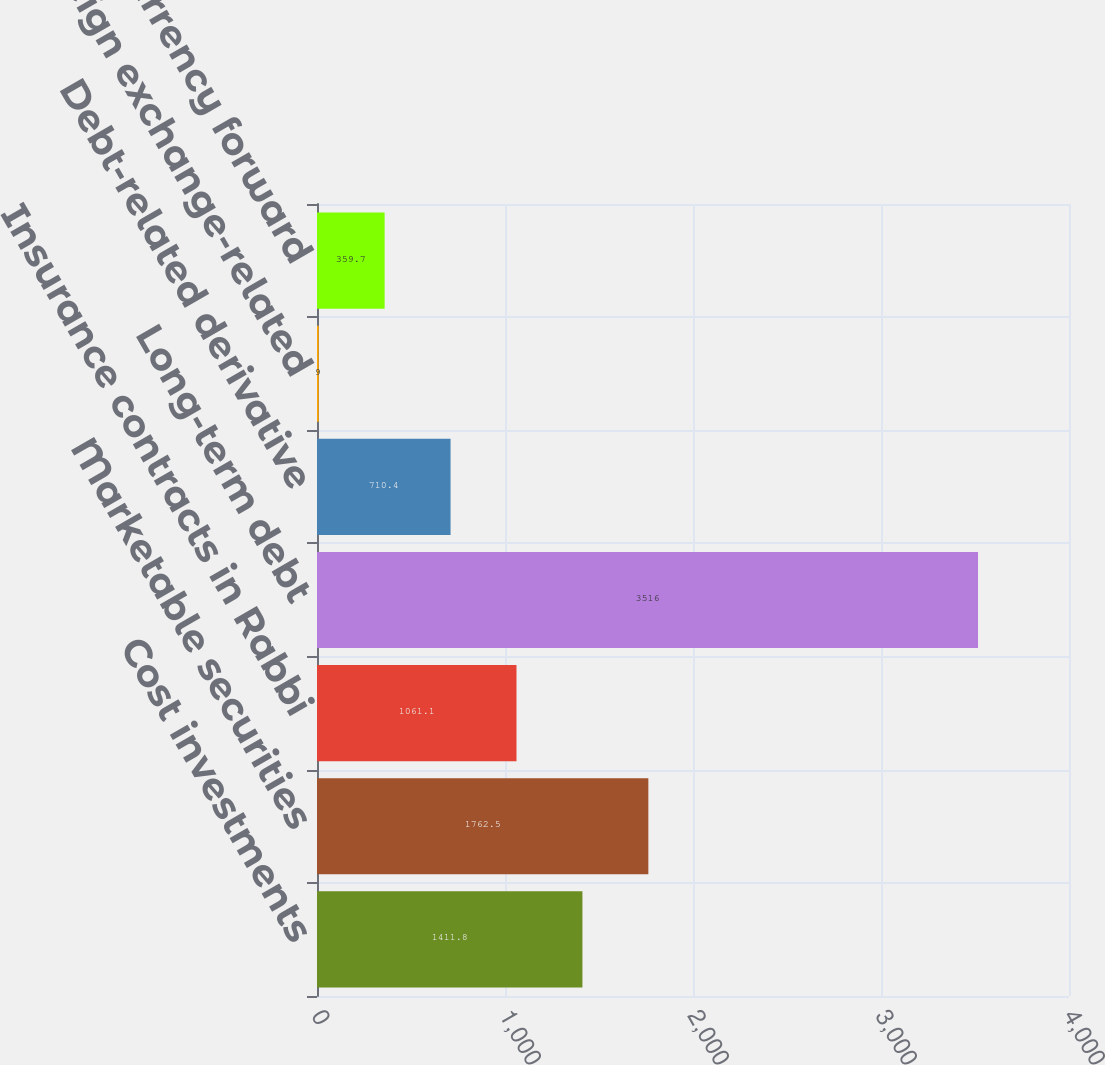Convert chart. <chart><loc_0><loc_0><loc_500><loc_500><bar_chart><fcel>Cost investments<fcel>Marketable securities<fcel>Insurance contracts in Rabbi<fcel>Long-term debt<fcel>Debt-related derivative<fcel>Foreign exchange-related<fcel>Foreign currency forward<nl><fcel>1411.8<fcel>1762.5<fcel>1061.1<fcel>3516<fcel>710.4<fcel>9<fcel>359.7<nl></chart> 